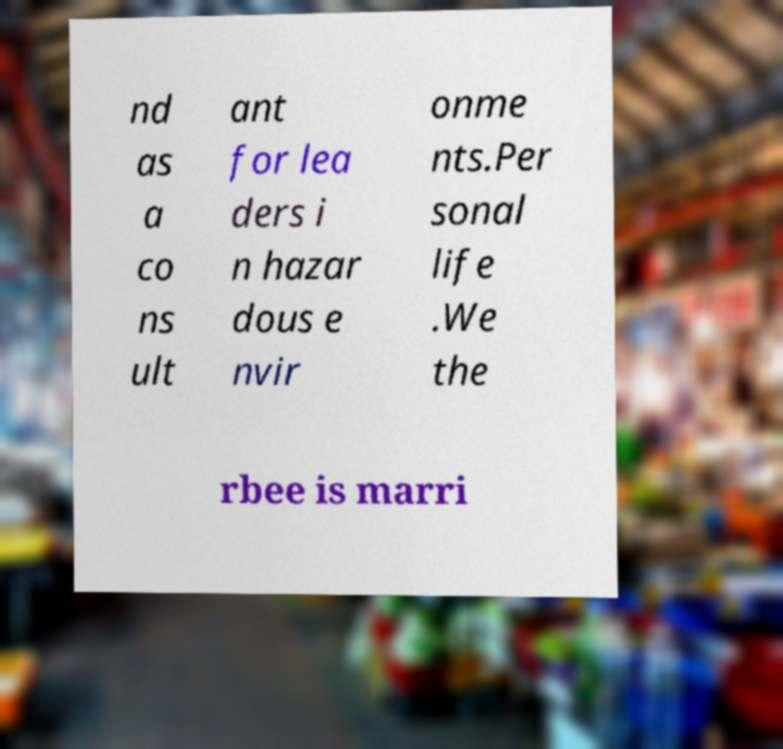Could you assist in decoding the text presented in this image and type it out clearly? nd as a co ns ult ant for lea ders i n hazar dous e nvir onme nts.Per sonal life .We the rbee is marri 